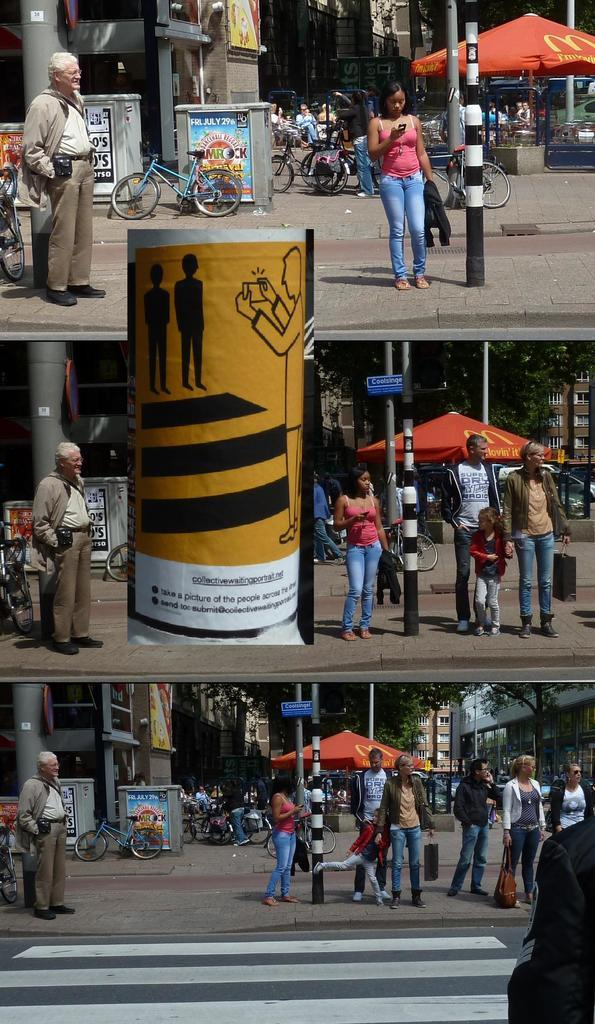<image>
Offer a succinct explanation of the picture presented. A ad is sitting downtown for Mrock festival on FRI July 29. 